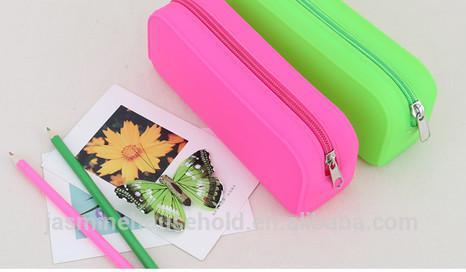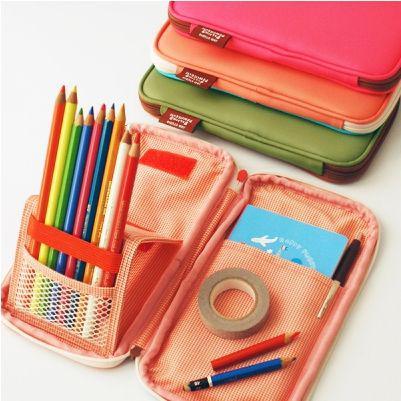The first image is the image on the left, the second image is the image on the right. Examine the images to the left and right. Is the description "box shaped pencil holders are folded open" accurate? Answer yes or no. No. The first image is the image on the left, the second image is the image on the right. For the images shown, is this caption "The left image contains only closed containers, the right has one open with multiple pencils inside." true? Answer yes or no. Yes. 